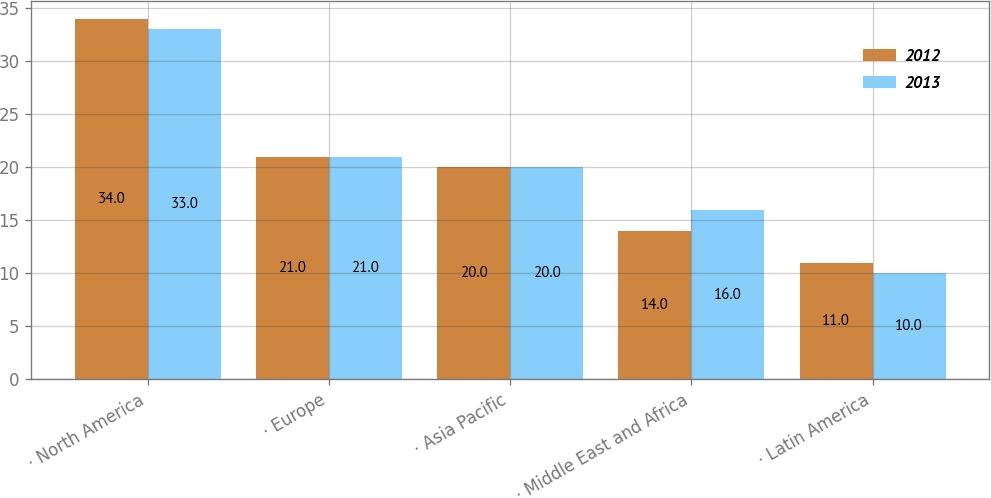Convert chart to OTSL. <chart><loc_0><loc_0><loc_500><loc_500><stacked_bar_chart><ecel><fcel>· North America<fcel>· Europe<fcel>· Asia Pacific<fcel>· Middle East and Africa<fcel>· Latin America<nl><fcel>2012<fcel>34<fcel>21<fcel>20<fcel>14<fcel>11<nl><fcel>2013<fcel>33<fcel>21<fcel>20<fcel>16<fcel>10<nl></chart> 